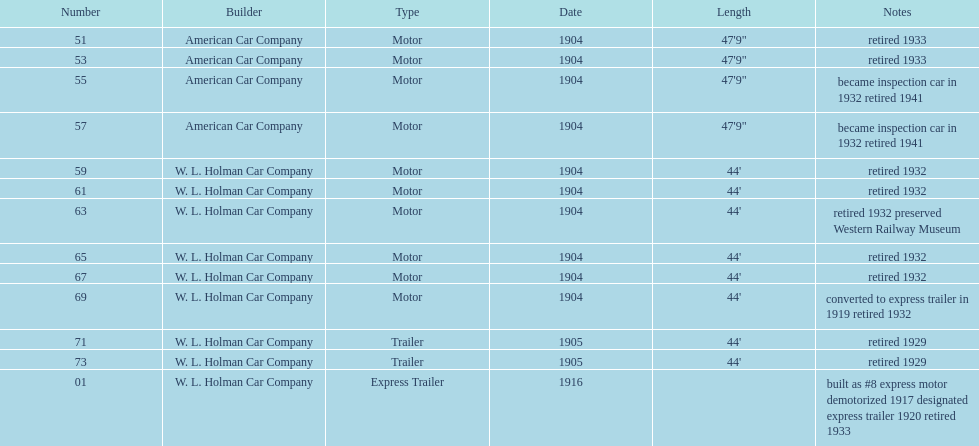How many cars were listed in total? 13. 